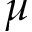<formula> <loc_0><loc_0><loc_500><loc_500>\mu</formula> 